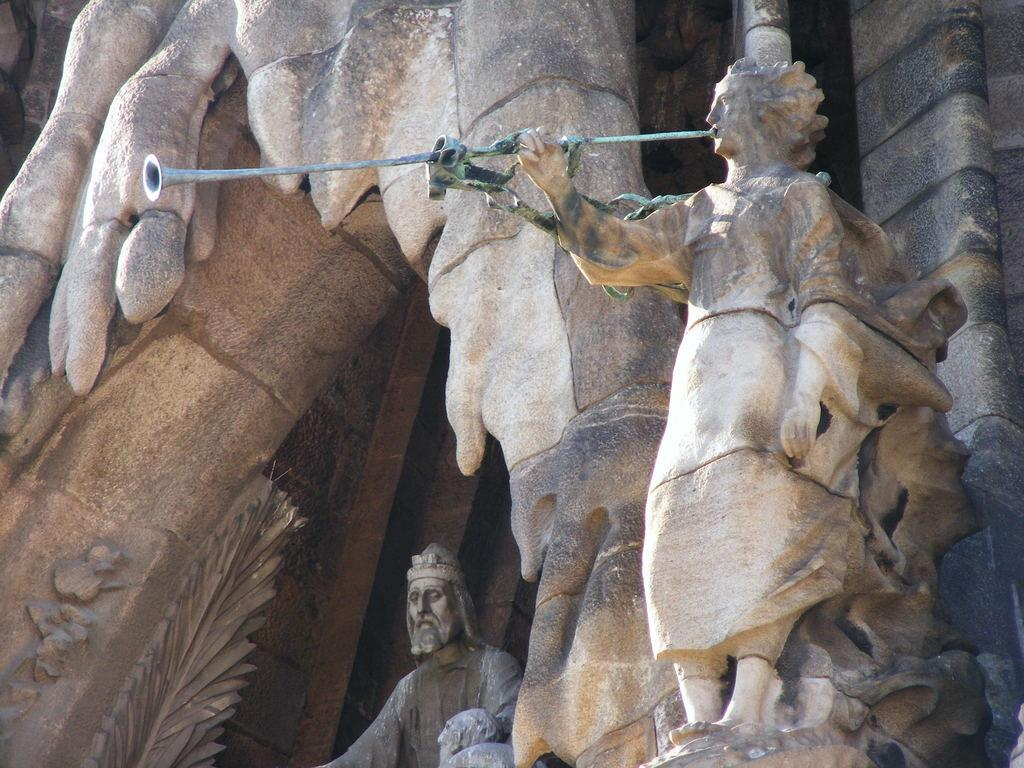What type of art can be seen in the image? There are sculptures in the image. What else is present in the image besides the sculptures? There are other objects in the image. Can you describe the designs on the wall in the image? Yes, there are designs on the wall in the image. How much wealth is represented by the gold ants in the image? There are no gold ants present in the image, so it is not possible to determine the amount of wealth represented. 